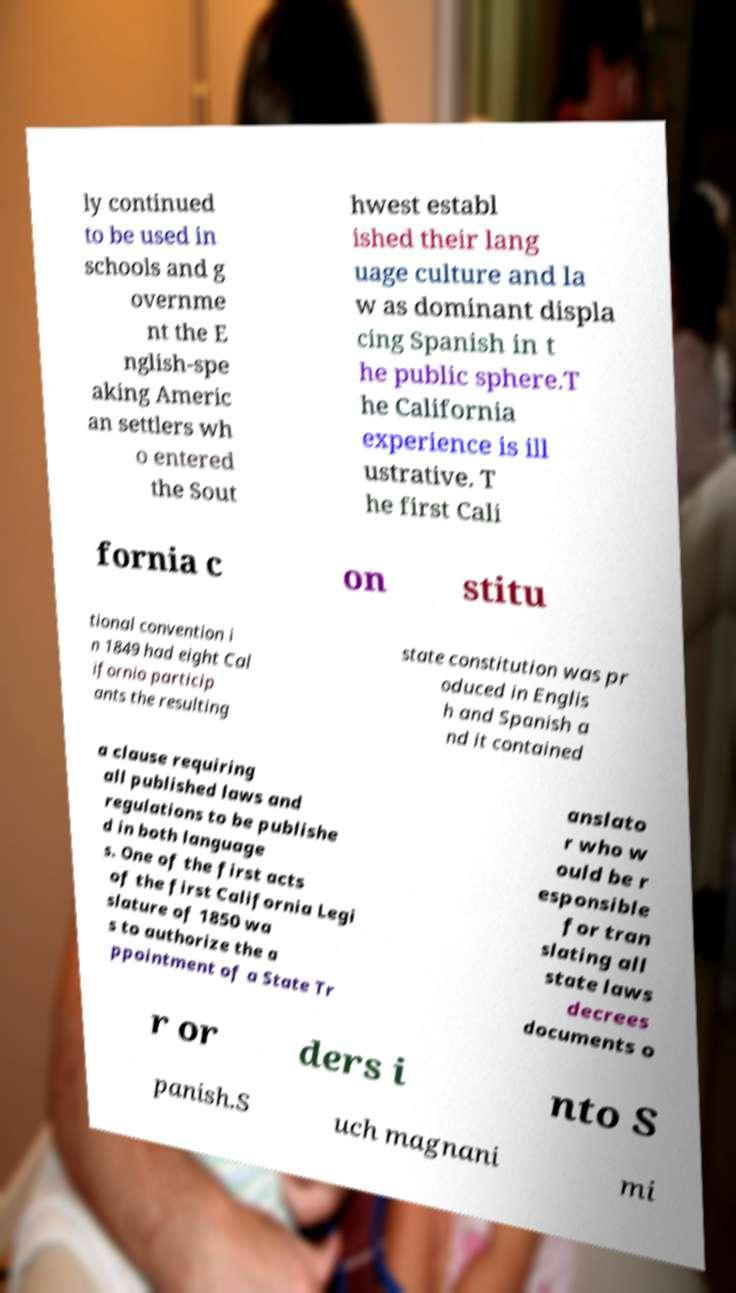Please identify and transcribe the text found in this image. ly continued to be used in schools and g overnme nt the E nglish-spe aking Americ an settlers wh o entered the Sout hwest establ ished their lang uage culture and la w as dominant displa cing Spanish in t he public sphere.T he California experience is ill ustrative. T he first Cali fornia c on stitu tional convention i n 1849 had eight Cal ifornio particip ants the resulting state constitution was pr oduced in Englis h and Spanish a nd it contained a clause requiring all published laws and regulations to be publishe d in both language s. One of the first acts of the first California Legi slature of 1850 wa s to authorize the a ppointment of a State Tr anslato r who w ould be r esponsible for tran slating all state laws decrees documents o r or ders i nto S panish.S uch magnani mi 